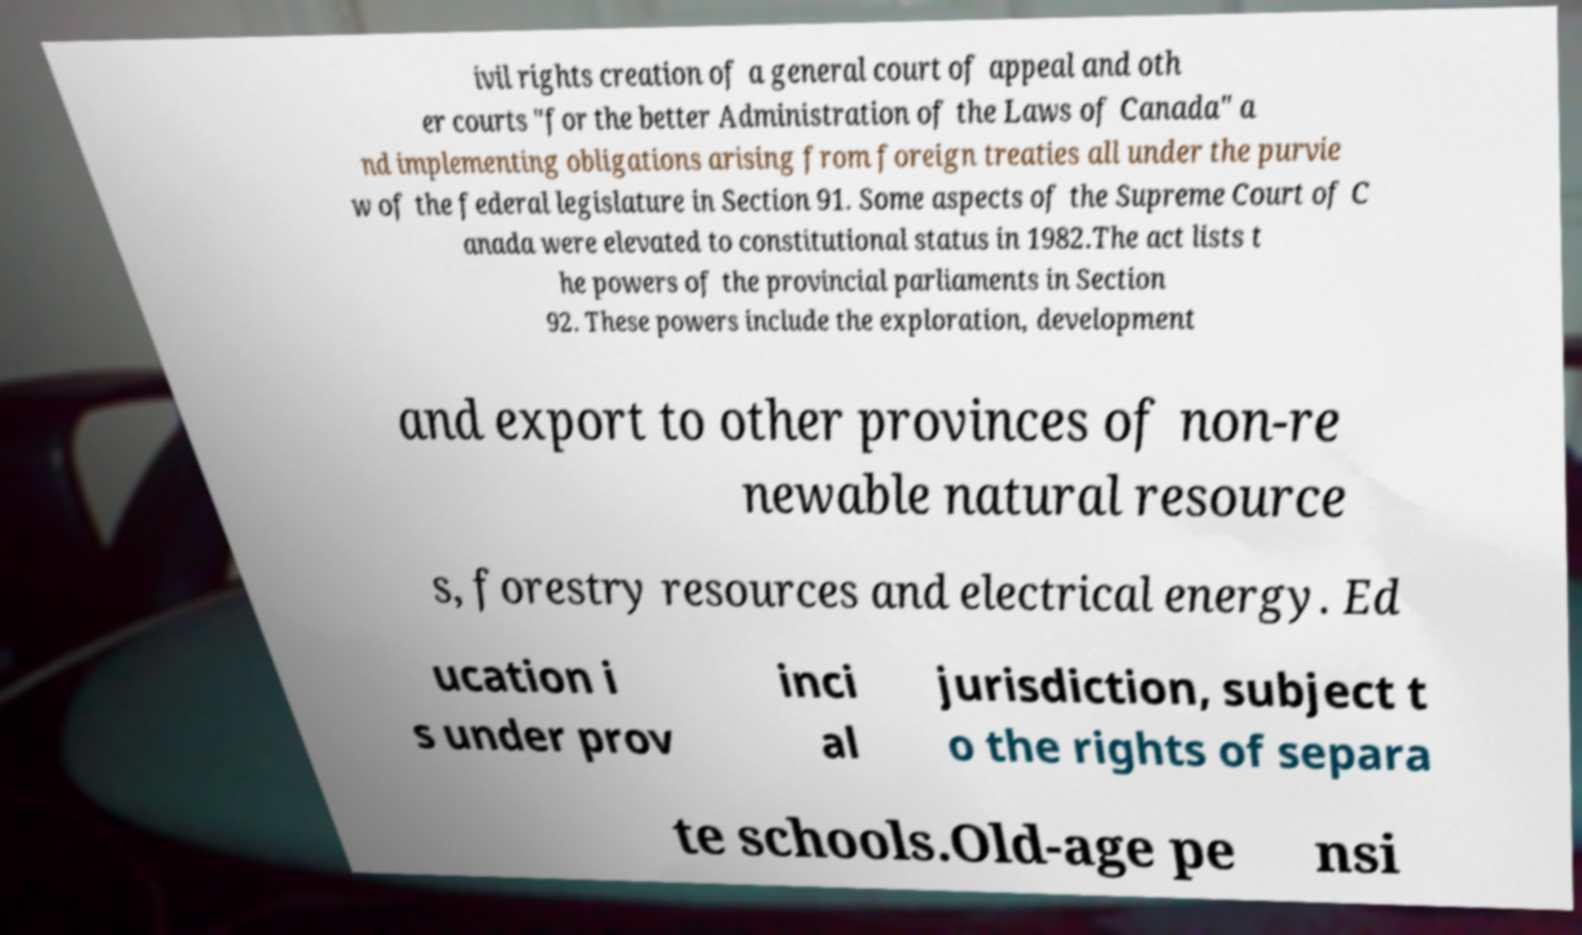Please read and relay the text visible in this image. What does it say? ivil rights creation of a general court of appeal and oth er courts "for the better Administration of the Laws of Canada" a nd implementing obligations arising from foreign treaties all under the purvie w of the federal legislature in Section 91. Some aspects of the Supreme Court of C anada were elevated to constitutional status in 1982.The act lists t he powers of the provincial parliaments in Section 92. These powers include the exploration, development and export to other provinces of non-re newable natural resource s, forestry resources and electrical energy. Ed ucation i s under prov inci al jurisdiction, subject t o the rights of separa te schools.Old-age pe nsi 